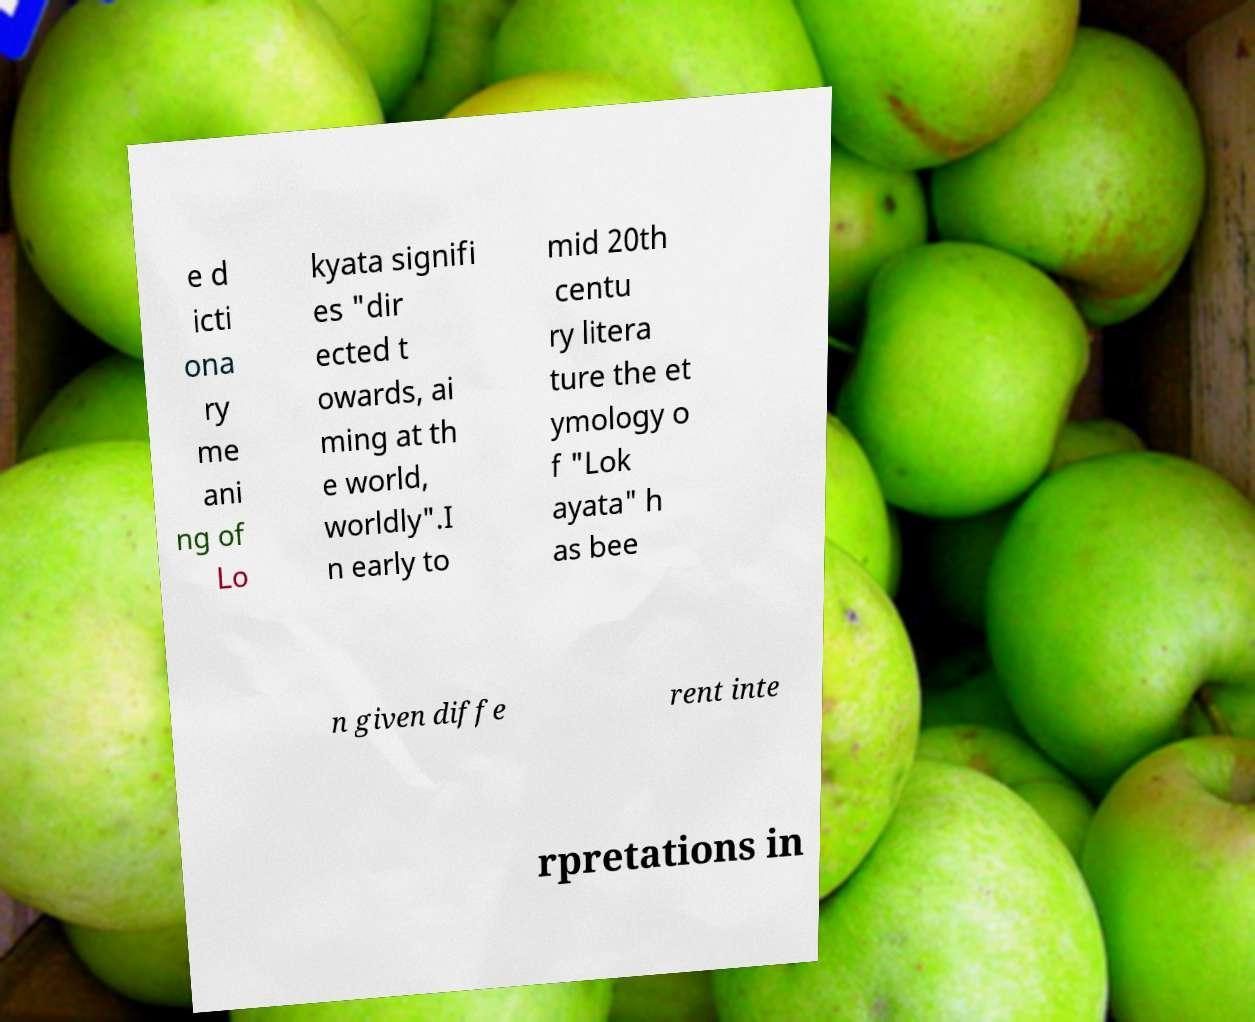What messages or text are displayed in this image? I need them in a readable, typed format. e d icti ona ry me ani ng of Lo kyata signifi es "dir ected t owards, ai ming at th e world, worldly".I n early to mid 20th centu ry litera ture the et ymology o f "Lok ayata" h as bee n given diffe rent inte rpretations in 